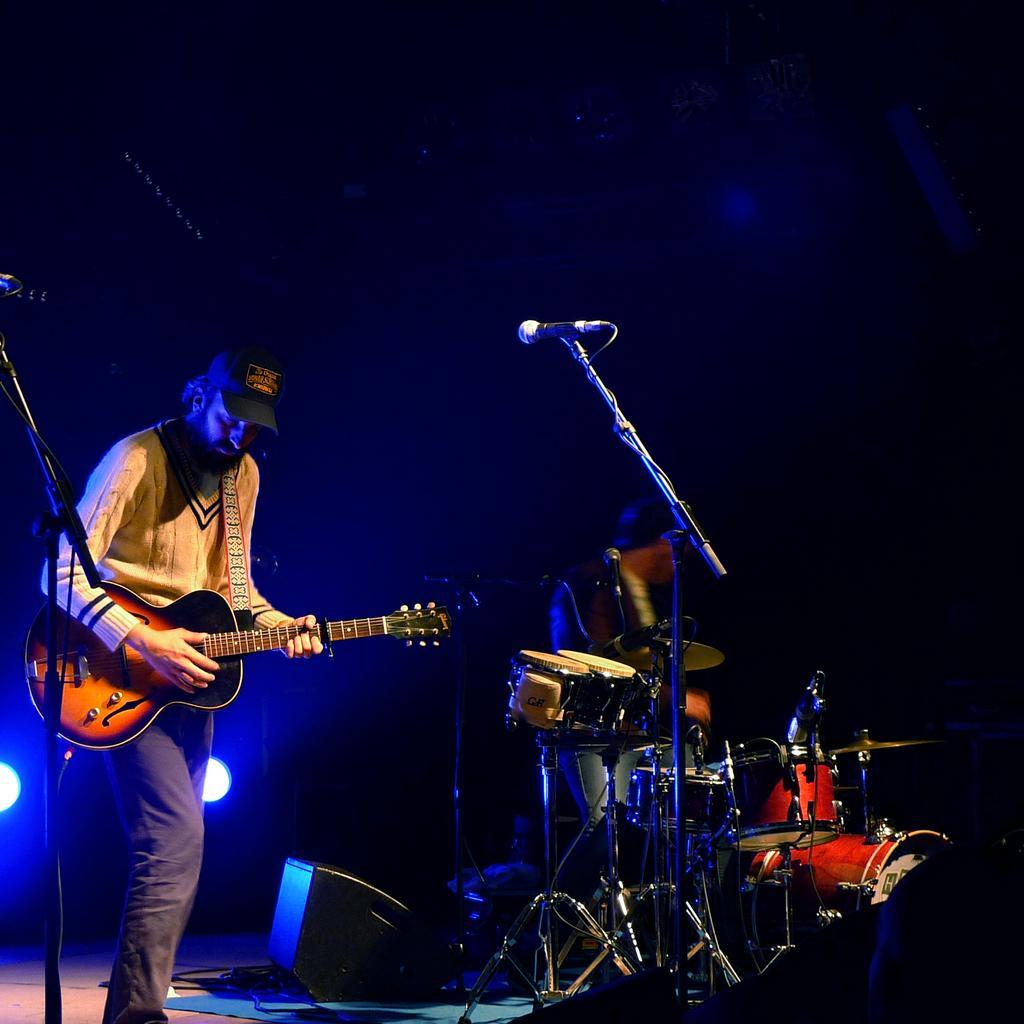Please provide a concise description of this image. In this picture there are two musicians playing a guitar with mics placed in front of them. In the picture there are several musical instruments placed and in the background we observe two LED lights. 